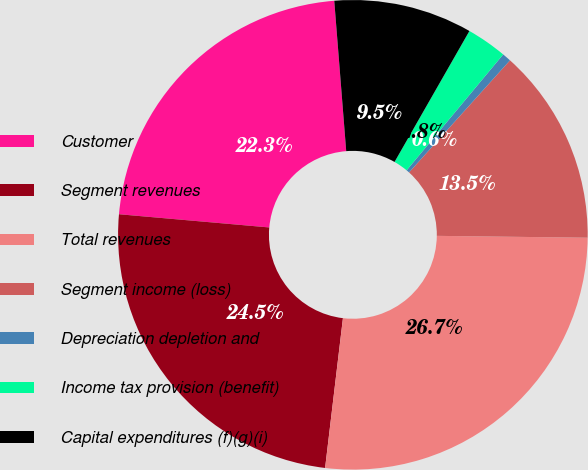Convert chart to OTSL. <chart><loc_0><loc_0><loc_500><loc_500><pie_chart><fcel>Customer<fcel>Segment revenues<fcel>Total revenues<fcel>Segment income (loss)<fcel>Depreciation depletion and<fcel>Income tax provision (benefit)<fcel>Capital expenditures (f)(g)(i)<nl><fcel>22.34%<fcel>24.51%<fcel>26.69%<fcel>13.53%<fcel>0.61%<fcel>2.79%<fcel>9.53%<nl></chart> 